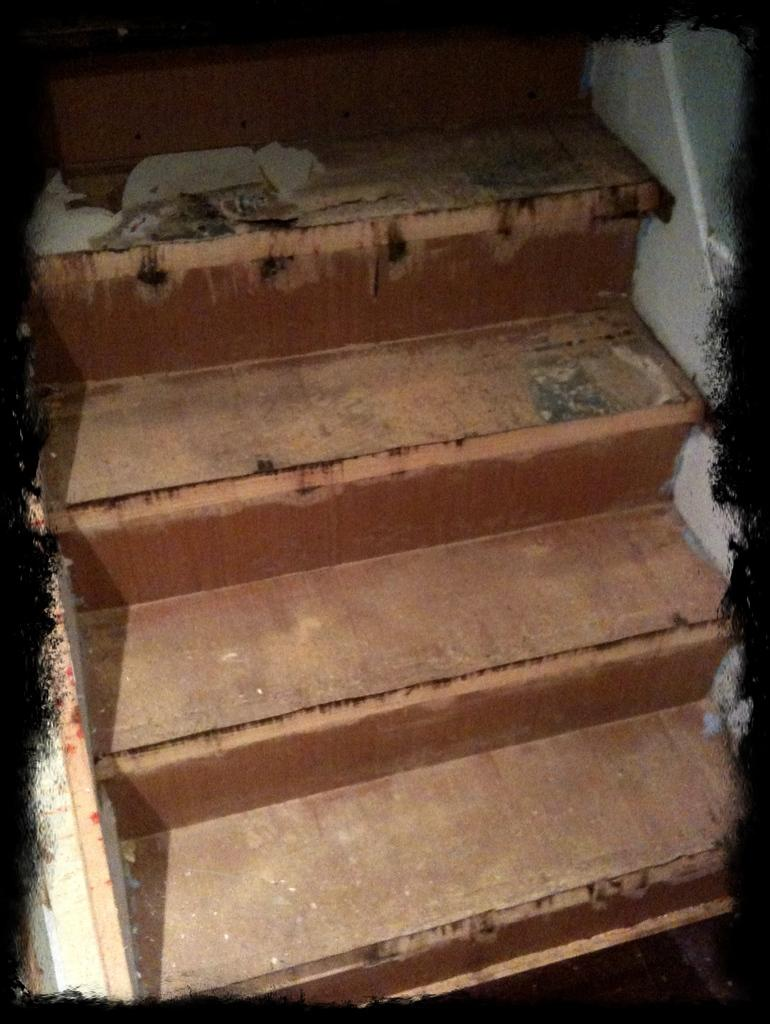What type of structure is present in the image? There are stairs in the image. Is there any additional detail around the stairs? Yes, there is a black border visible around the stairs. How many ducks can be seen in the wilderness in the image? There are no ducks or wilderness present in the image; it only features stairs with a black border. 